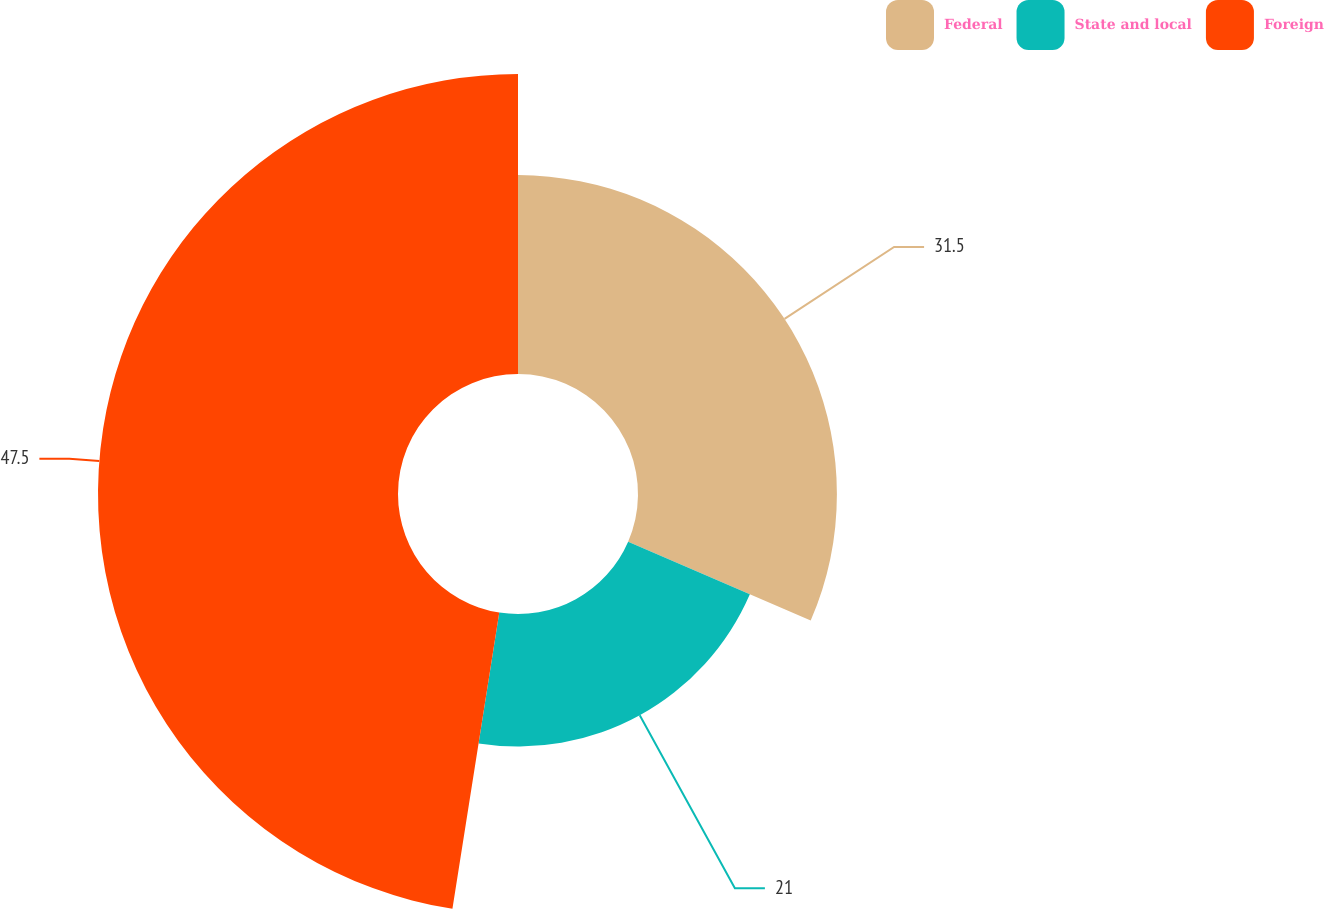Convert chart to OTSL. <chart><loc_0><loc_0><loc_500><loc_500><pie_chart><fcel>Federal<fcel>State and local<fcel>Foreign<nl><fcel>31.5%<fcel>21.0%<fcel>47.51%<nl></chart> 